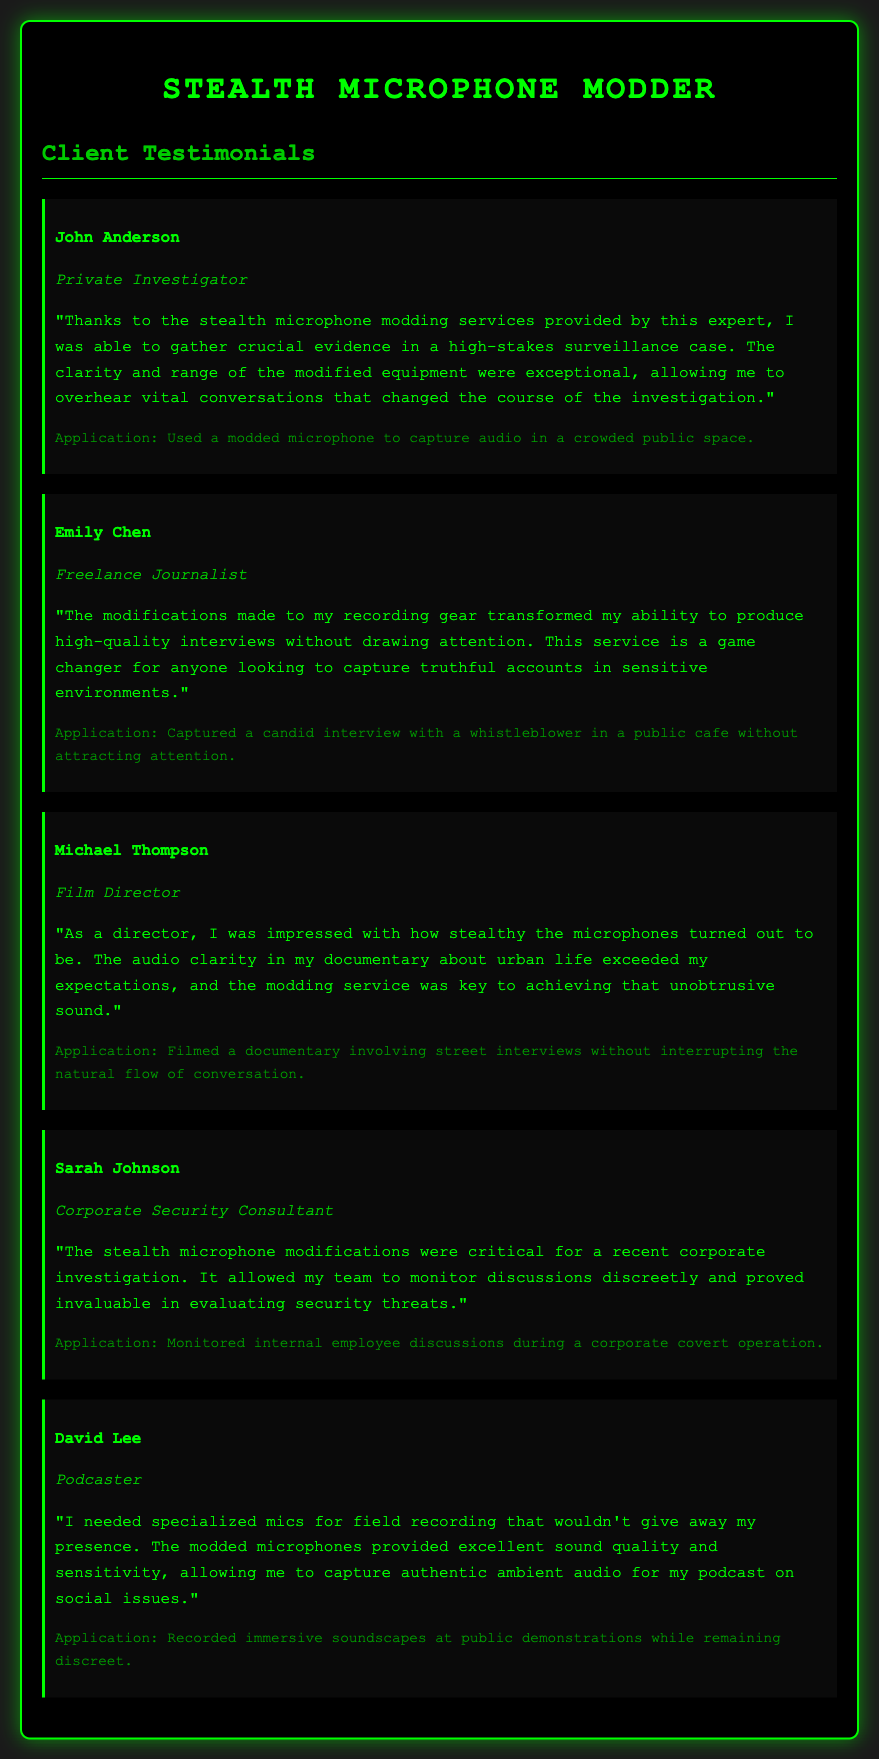What is the name of the private investigator? The document mentions John Anderson as the private investigator.
Answer: John Anderson Which client profession is identified as a freelance journalist? The document specifies Emily Chen as the freelance journalist.
Answer: Emily Chen What was Michael Thompson's role in the project? According to the document, Michael Thompson is a film director.
Answer: Film Director What unique ability did the modifications provide for the journalist? The document states that the modifications transformed the journalist's ability to produce high-quality interviews.
Answer: High-quality interviews In what type of location did Sarah Johnson's team monitor discussions? The document indicates that the monitoring was done during a corporate covert operation.
Answer: Corporate covert operation How did the stealth microphones benefit David Lee's podcast? The document highlights that the modded microphones provided excellent sound quality and sensitivity for field recording.
Answer: Excellent sound quality and sensitivity What was the application of the modded microphone by John Anderson? The document details that John used a modded microphone to capture audio in a crowded public space.
Answer: Crowded public space Which client praised the sound clarity for documentary filming? The document attributes the praise for sound clarity in a documentary to Michael Thompson.
Answer: Michael Thompson 